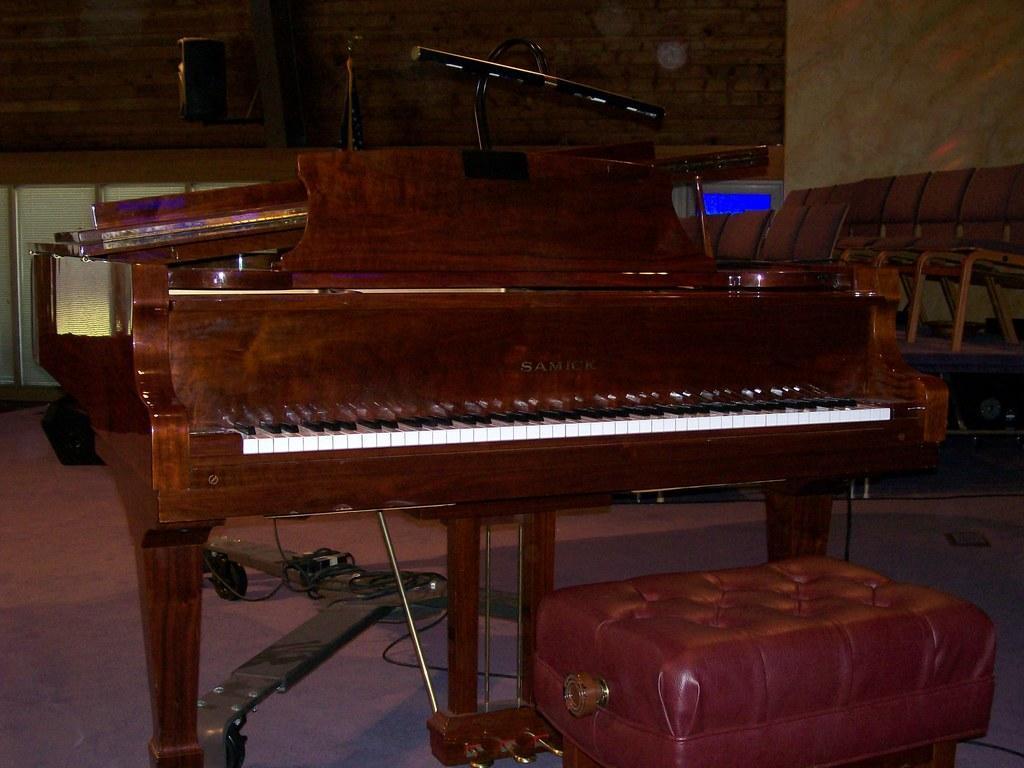In one or two sentences, can you explain what this image depicts? In this picture i could see a piano which is brown in color and in front of piano there is a small chair and to the right side of the picture there are brown colored chairs arranged in a row and in the background there is another wall which is brown in color. 